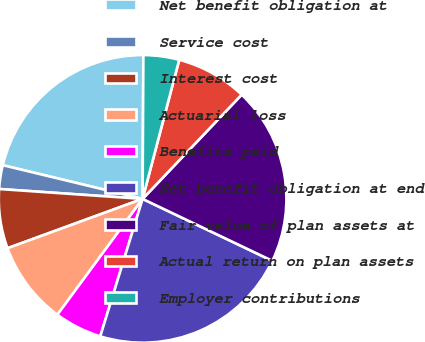<chart> <loc_0><loc_0><loc_500><loc_500><pie_chart><fcel>Net benefit obligation at<fcel>Service cost<fcel>Interest cost<fcel>Actuarial loss<fcel>Benefits paid<fcel>Net benefit obligation at end<fcel>Fair value of plan assets at<fcel>Actual return on plan assets<fcel>Employer contributions<nl><fcel>21.32%<fcel>2.67%<fcel>6.67%<fcel>9.33%<fcel>5.34%<fcel>22.66%<fcel>19.99%<fcel>8.0%<fcel>4.01%<nl></chart> 